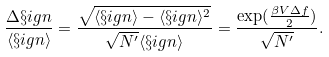<formula> <loc_0><loc_0><loc_500><loc_500>\frac { \Delta \S i g n } { \langle \S i g n \rangle } = \frac { \sqrt { \langle \S i g n \rangle - \langle \S i g n \rangle ^ { 2 } } } { \sqrt { N ^ { \prime } } { \langle \S i g n \rangle } } = \frac { \exp ( \frac { \beta V \Delta f } { 2 } ) } { \sqrt { N ^ { \prime } } } .</formula> 